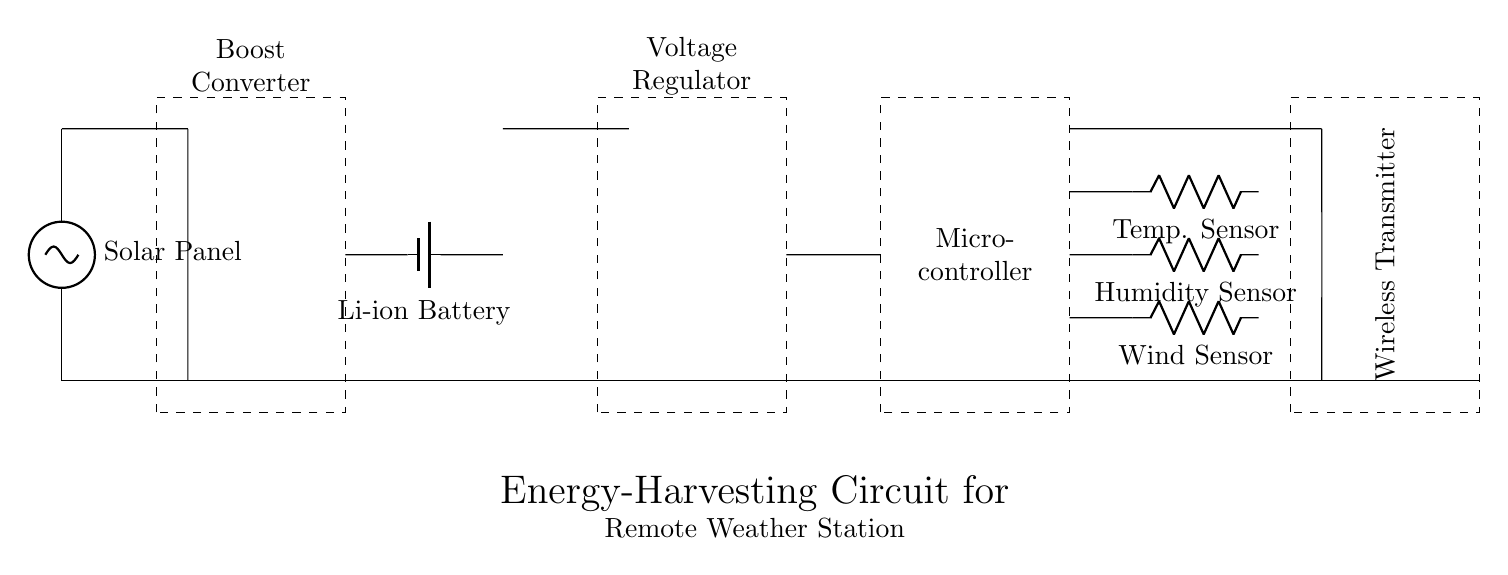What component is used to harvest energy in this circuit? The component responsible for harvesting energy in this circuit is the solar panel, which is represented at the beginning of the circuit diagram.
Answer: Solar panel What kind of battery is included in the circuit? The battery type used in the circuit is specified as a lithium-ion battery, which is marked in the diagram, indicating it is rechargeable and suitable for energy storage.
Answer: Li-ion battery How many sensors are connected to the microcontroller? Three sensors are connected to the microcontroller, as indicated by the three distinct connections branching from it in the circuit diagram for temperature, humidity, and wind measurement.
Answer: Three What is the function of the boost converter in this circuit? The boost converter's function is to increase the voltage provided by the solar panel to a suitable level needed for charging the battery and powering other components, which is essential for energy management in the circuit.
Answer: Increase voltage What is the output component that transmits data? The output component used for transmitting data in this circuit is the wireless transmitter, which connects to the microcontroller and is indicated by the dashed rectangle, highlighting its key role in communication.
Answer: Wireless transmitter How does the energy flow from the solar panel to the sensors? The energy flow begins at the solar panel, then moves through the boost converter to the battery, from which it passes through the voltage regulator before finally reaching the microcontroller and sensors, enabling their operation for data collection.
Answer: From solar panel to boost converter, battery, voltage regulator, microcontroller, and sensors What is the purpose of the voltage regulator in this circuit? The voltage regulator's purpose is to ensure that the output voltage remains constant and within the required range for the microcontroller and sensors despite variations in the input voltage from the solar panel and battery, which is crucial for the reliability of the system.
Answer: Stabilize voltage 